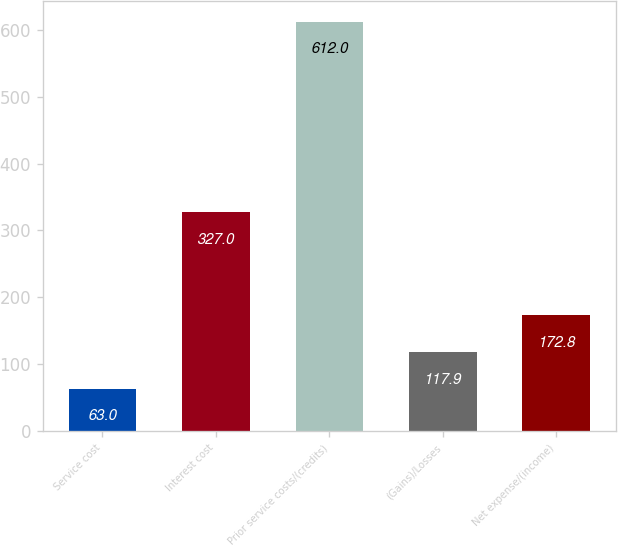Convert chart. <chart><loc_0><loc_0><loc_500><loc_500><bar_chart><fcel>Service cost<fcel>Interest cost<fcel>Prior service costs/(credits)<fcel>(Gains)/Losses<fcel>Net expense/(income)<nl><fcel>63<fcel>327<fcel>612<fcel>117.9<fcel>172.8<nl></chart> 